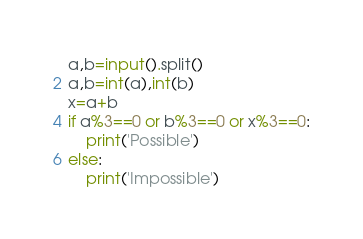<code> <loc_0><loc_0><loc_500><loc_500><_Python_>a,b=input().split()
a,b=int(a),int(b)
x=a+b
if a%3==0 or b%3==0 or x%3==0:
    print('Possible')
else:
    print('Impossible')</code> 